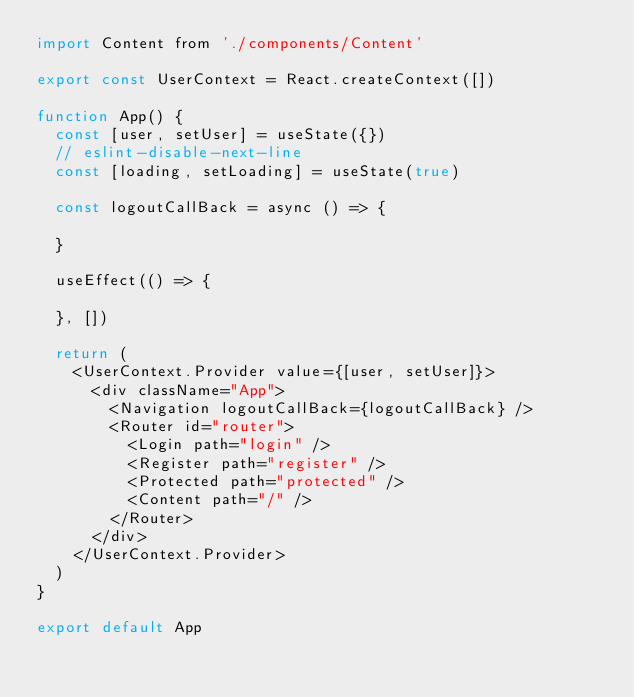Convert code to text. <code><loc_0><loc_0><loc_500><loc_500><_JavaScript_>import Content from './components/Content'

export const UserContext = React.createContext([])

function App() {
  const [user, setUser] = useState({})
  // eslint-disable-next-line
  const [loading, setLoading] = useState(true)

  const logoutCallBack = async () => {

  }

  useEffect(() => {
    
  }, [])

  return (
    <UserContext.Provider value={[user, setUser]}>
      <div className="App">
        <Navigation logoutCallBack={logoutCallBack} />
        <Router id="router">
          <Login path="login" />
          <Register path="register" />
          <Protected path="protected" />
          <Content path="/" />
        </Router>
      </div>
    </UserContext.Provider>
  )
}

export default App
</code> 